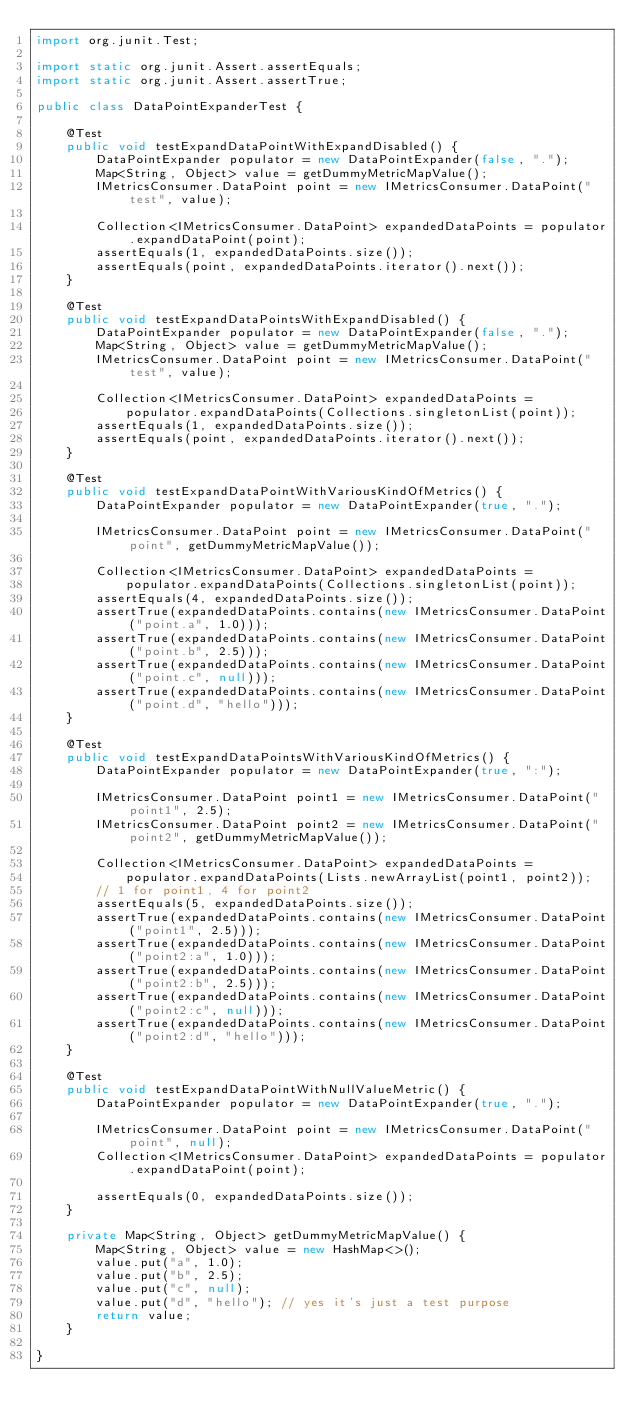Convert code to text. <code><loc_0><loc_0><loc_500><loc_500><_Java_>import org.junit.Test;

import static org.junit.Assert.assertEquals;
import static org.junit.Assert.assertTrue;

public class DataPointExpanderTest {

    @Test
    public void testExpandDataPointWithExpandDisabled() {
        DataPointExpander populator = new DataPointExpander(false, ".");
        Map<String, Object> value = getDummyMetricMapValue();
        IMetricsConsumer.DataPoint point = new IMetricsConsumer.DataPoint("test", value);

        Collection<IMetricsConsumer.DataPoint> expandedDataPoints = populator.expandDataPoint(point);
        assertEquals(1, expandedDataPoints.size());
        assertEquals(point, expandedDataPoints.iterator().next());
    }

    @Test
    public void testExpandDataPointsWithExpandDisabled() {
        DataPointExpander populator = new DataPointExpander(false, ".");
        Map<String, Object> value = getDummyMetricMapValue();
        IMetricsConsumer.DataPoint point = new IMetricsConsumer.DataPoint("test", value);

        Collection<IMetricsConsumer.DataPoint> expandedDataPoints =
            populator.expandDataPoints(Collections.singletonList(point));
        assertEquals(1, expandedDataPoints.size());
        assertEquals(point, expandedDataPoints.iterator().next());
    }

    @Test
    public void testExpandDataPointWithVariousKindOfMetrics() {
        DataPointExpander populator = new DataPointExpander(true, ".");

        IMetricsConsumer.DataPoint point = new IMetricsConsumer.DataPoint("point", getDummyMetricMapValue());

        Collection<IMetricsConsumer.DataPoint> expandedDataPoints =
            populator.expandDataPoints(Collections.singletonList(point));
        assertEquals(4, expandedDataPoints.size());
        assertTrue(expandedDataPoints.contains(new IMetricsConsumer.DataPoint("point.a", 1.0)));
        assertTrue(expandedDataPoints.contains(new IMetricsConsumer.DataPoint("point.b", 2.5)));
        assertTrue(expandedDataPoints.contains(new IMetricsConsumer.DataPoint("point.c", null)));
        assertTrue(expandedDataPoints.contains(new IMetricsConsumer.DataPoint("point.d", "hello")));
    }

    @Test
    public void testExpandDataPointsWithVariousKindOfMetrics() {
        DataPointExpander populator = new DataPointExpander(true, ":");

        IMetricsConsumer.DataPoint point1 = new IMetricsConsumer.DataPoint("point1", 2.5);
        IMetricsConsumer.DataPoint point2 = new IMetricsConsumer.DataPoint("point2", getDummyMetricMapValue());

        Collection<IMetricsConsumer.DataPoint> expandedDataPoints =
            populator.expandDataPoints(Lists.newArrayList(point1, point2));
        // 1 for point1, 4 for point2
        assertEquals(5, expandedDataPoints.size());
        assertTrue(expandedDataPoints.contains(new IMetricsConsumer.DataPoint("point1", 2.5)));
        assertTrue(expandedDataPoints.contains(new IMetricsConsumer.DataPoint("point2:a", 1.0)));
        assertTrue(expandedDataPoints.contains(new IMetricsConsumer.DataPoint("point2:b", 2.5)));
        assertTrue(expandedDataPoints.contains(new IMetricsConsumer.DataPoint("point2:c", null)));
        assertTrue(expandedDataPoints.contains(new IMetricsConsumer.DataPoint("point2:d", "hello")));
    }

    @Test
    public void testExpandDataPointWithNullValueMetric() {
        DataPointExpander populator = new DataPointExpander(true, ".");

        IMetricsConsumer.DataPoint point = new IMetricsConsumer.DataPoint("point", null);
        Collection<IMetricsConsumer.DataPoint> expandedDataPoints = populator.expandDataPoint(point);

        assertEquals(0, expandedDataPoints.size());
    }

    private Map<String, Object> getDummyMetricMapValue() {
        Map<String, Object> value = new HashMap<>();
        value.put("a", 1.0);
        value.put("b", 2.5);
        value.put("c", null);
        value.put("d", "hello"); // yes it's just a test purpose
        return value;
    }

}
</code> 